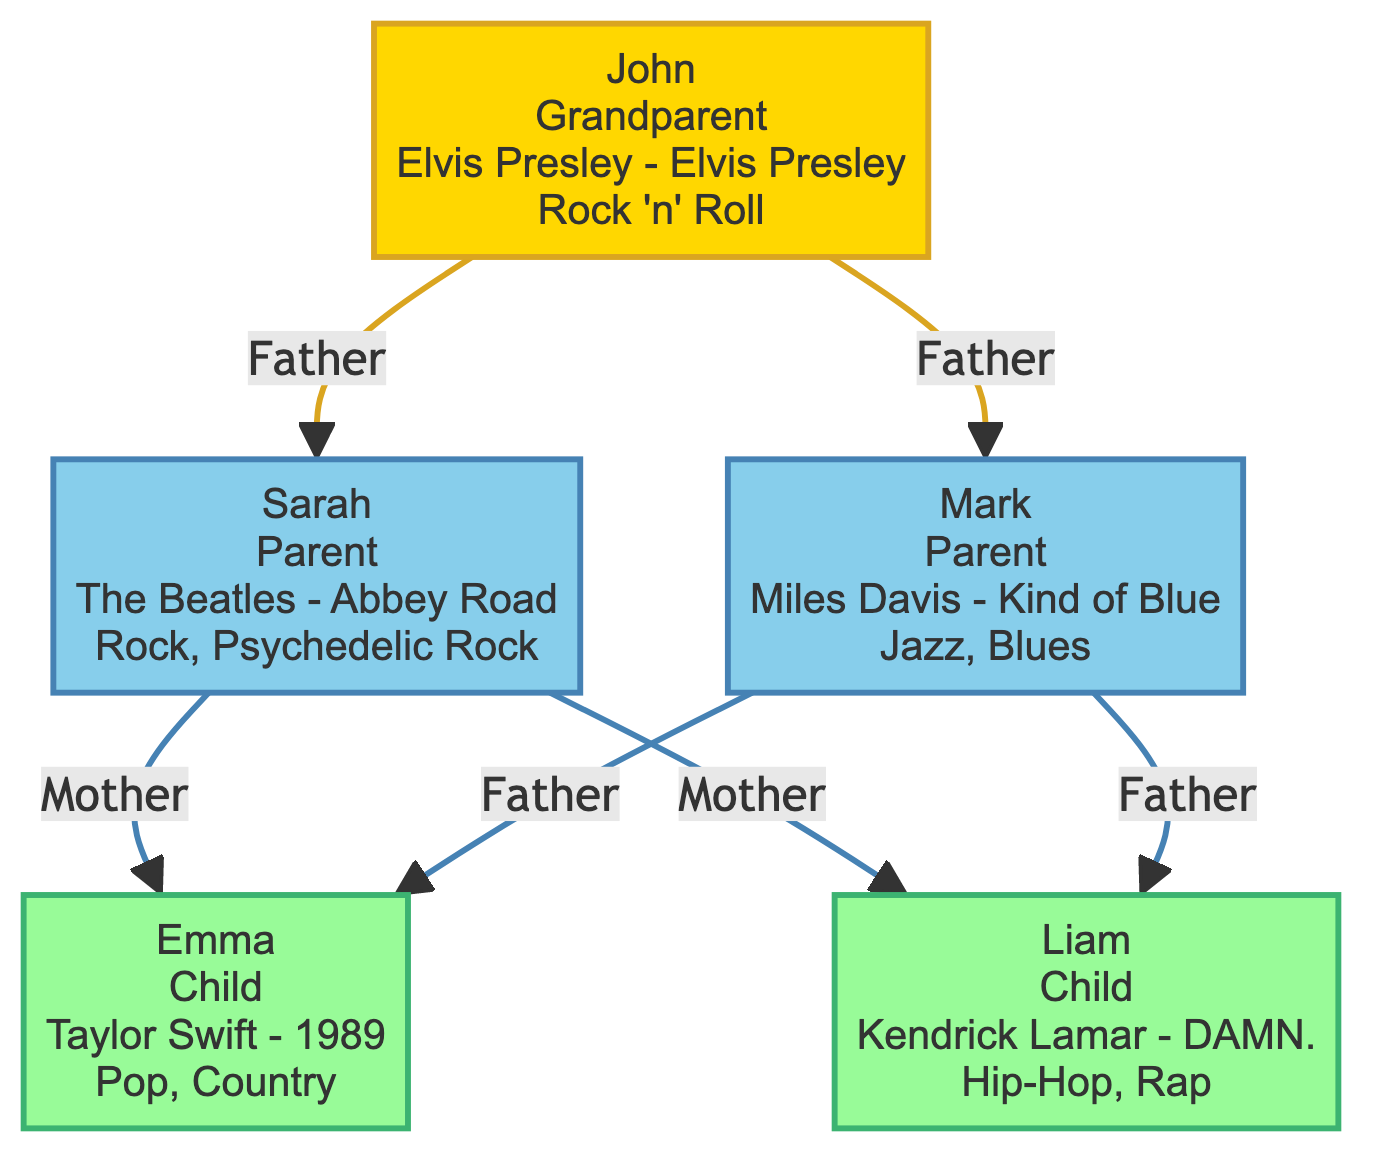What is John’s favorite album? The diagram shows John, the grandparent, has the favorite album "Elvis Presley - Elvis Presley." This information is provided clearly within his node.
Answer: Elvis Presley - Elvis Presley How many children does Sarah have? The diagram presents Sarah, the parent, with direct connections leading to two children: Emma and Liam. Thus, she has two children indicated through the edges from her node.
Answer: 2 What musical genre does Liam prefer? In the diagram, Liam's node lists his favorite album, "Kendrick Lamar - DAMN.," along with the declared musical influences of "Hip-Hop" and "Rap." This description directly identifies his preferred genre.
Answer: Hip-Hop, Rap Who is the father of Emma? The diagram explicitly shows both Sarah and Mark as parents of Emma through edges connecting them to her node. Both are identified with the relationship of Father from Mark and Mother from Sarah, but only one parent can be asked here. Since Mark is specifically mentioned as her father in the relationship edge, he is the answer.
Answer: Mark What are the musical influences of John? John's node details that his musical influence stems from "Rock 'n' Roll." This information is provided within the node, clearly stating what genres influenced him.
Answer: Rock 'n' Roll How is Liam related to John? Examining the edges leading to Liam's node, he is a child of both Sarah and Mark, who are grandchildren of John. Therefore, Liam is directly related to John as a grandchild.
Answer: Grandchild Which album is favored by both parents? The diagram reveals that Sarah and Mark, both parents, have distinct favorite albums: "The Beatles - Abbey Road" and "Miles Davis - Kind of Blue," indicating they do not share a favorite album, thus the answer is that no album is favored by both.
Answer: None What genre is Sarah's favorite album associated with? The node for Sarah specifies her favorite album as "The Beatles - Abbey Road" and lists her musical influences as "Rock" and "Psychedelic Rock." Thus, the genres directly associated with her favorite album are part of the listed influences.
Answer: Rock, Psychedelic Rock How many total nodes are in the diagram? The diagram includes five nodes representing different family members: John, Sarah, Mark, Emma, and Liam. Counting them gives the total number of nodes depicted here.
Answer: 5 